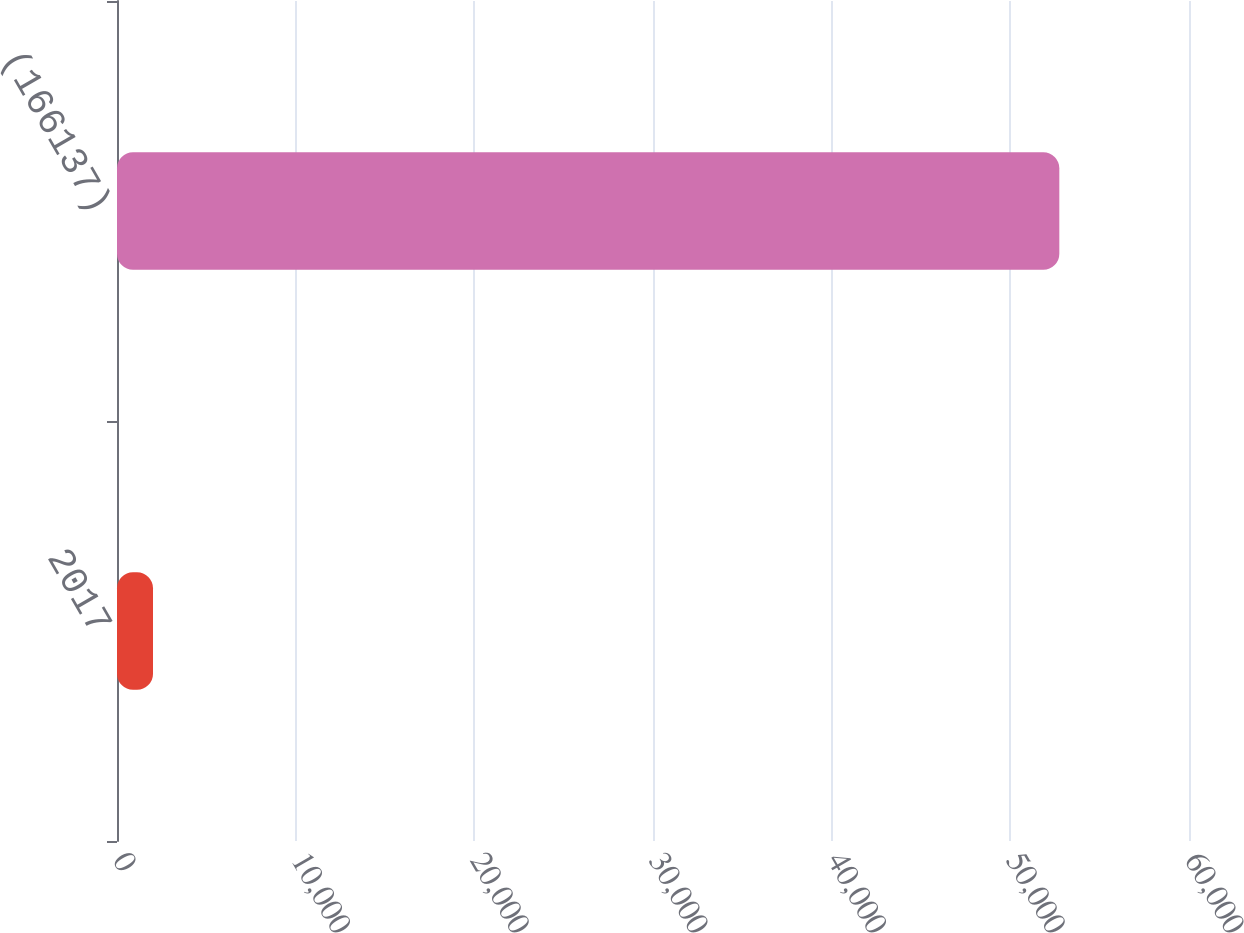Convert chart. <chart><loc_0><loc_0><loc_500><loc_500><bar_chart><fcel>2017<fcel>(166137)<nl><fcel>2015<fcel>52742<nl></chart> 